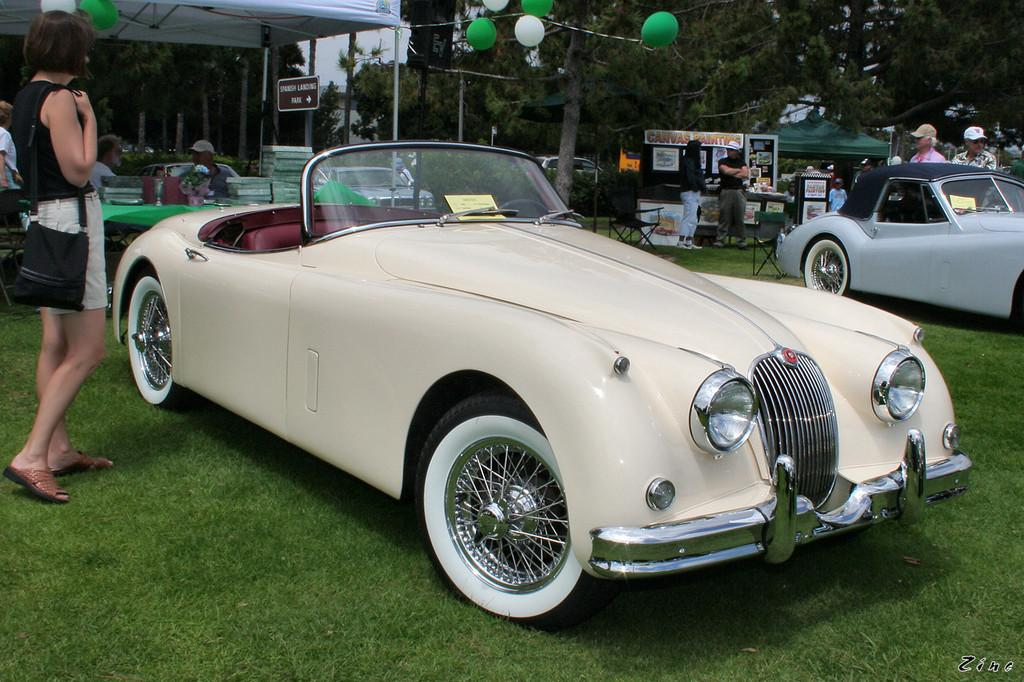What type of vehicles can be seen on the grass in the image? There are cars on the grass in the image. Can you describe the people in the image? There are persons in the image. What decorative items are present in the image? Balloons are present in the image. What structures can be seen in the image? Poles are visible in the image. What furniture items are in the image? Boards, tables, chairs, and stools are in the image. What can be seen in the background of the image? The sky is visible in the background of the image. What type of yoke is being used to carry the balloons in the image? There is no yoke present in the image, and the balloons are not being carried by any such device. What store can be seen in the background of the image? There is no store visible in the image; only the sky is visible in the background. 